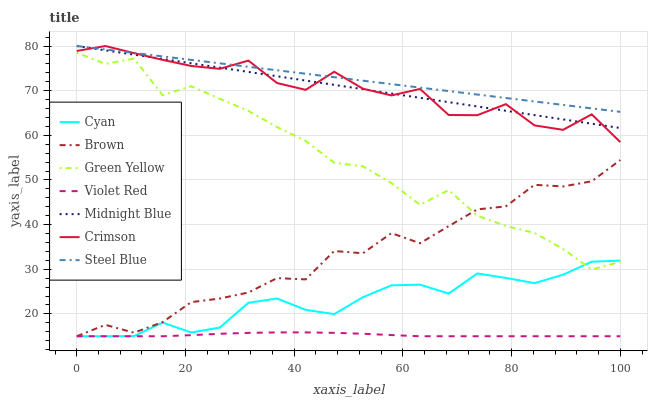Does Violet Red have the minimum area under the curve?
Answer yes or no. Yes. Does Steel Blue have the maximum area under the curve?
Answer yes or no. Yes. Does Midnight Blue have the minimum area under the curve?
Answer yes or no. No. Does Midnight Blue have the maximum area under the curve?
Answer yes or no. No. Is Midnight Blue the smoothest?
Answer yes or no. Yes. Is Crimson the roughest?
Answer yes or no. Yes. Is Violet Red the smoothest?
Answer yes or no. No. Is Violet Red the roughest?
Answer yes or no. No. Does Brown have the lowest value?
Answer yes or no. Yes. Does Midnight Blue have the lowest value?
Answer yes or no. No. Does Crimson have the highest value?
Answer yes or no. Yes. Does Violet Red have the highest value?
Answer yes or no. No. Is Cyan less than Crimson?
Answer yes or no. Yes. Is Steel Blue greater than Brown?
Answer yes or no. Yes. Does Violet Red intersect Cyan?
Answer yes or no. Yes. Is Violet Red less than Cyan?
Answer yes or no. No. Is Violet Red greater than Cyan?
Answer yes or no. No. Does Cyan intersect Crimson?
Answer yes or no. No. 